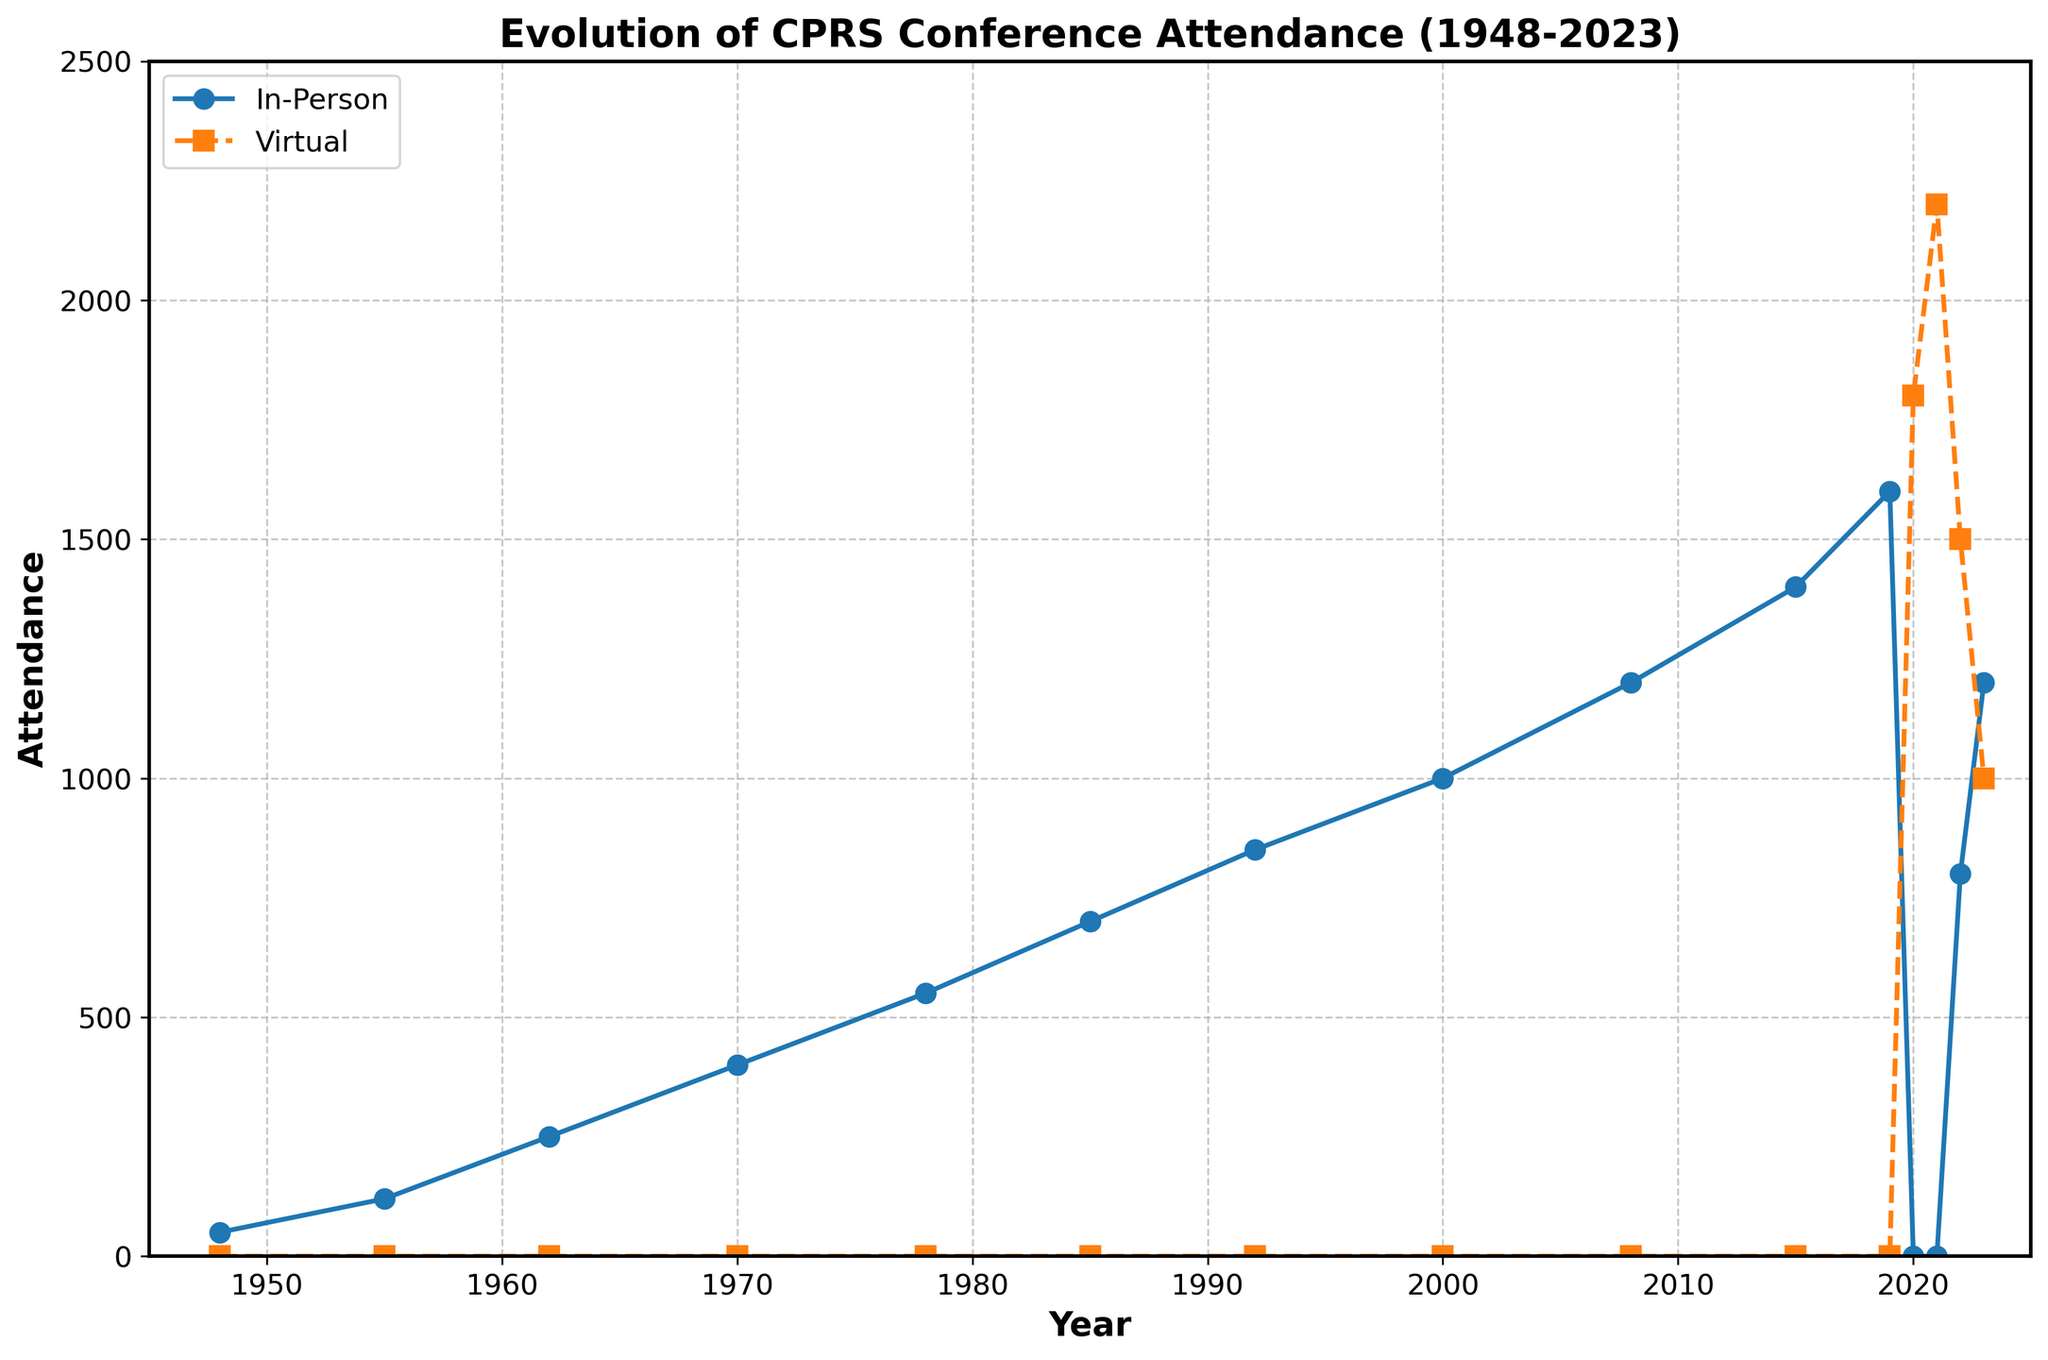What was the in-person attendance in 1978? Refer to the in-person attendance line on the chart and look at the year 1978. The chart shows a dot at 550 for this year.
Answer: 550 How did the virtual attendance in 2020 compare to in-person attendance in 2019? For 2020, the virtual attendance was 1800, and in 2019, the in-person attendance was 1600. Comparing these, 1800 is greater than 1600.
Answer: Virtual attendance in 2020 was higher What is the difference between total attendance (in-person plus virtual) in 2020 and 2022? In 2020, total attendance was 1800 (since only virtual attendance was present). In 2022, total attendance equals 800 (in-person) + 1500 (virtual) = 2300. Subtract 1800 from 2300.
Answer: 500 Which year saw the highest virtual attendance? Look at the virtual attendance (dashed line) and identify the highest point, which is in 2021 with an attendance of 2200.
Answer: 2021 How did the in-person attendance trend change between 2019 and 2023? Refer to the in-person attendance line on the chart. From 2019 (1600), the attendance dropped to 0 in 2020 and 2021, then rose to 800 in 2022 and further to 1200 in 2023.
Answer: It dropped to zero and then gradually increased What year saw the first introduction of virtual attendance? Observe the virtual attendance line (dashed). The first nonzero value appears in 2020.
Answer: 2020 What is the average in-person attendance from 1948 to 2023? Sum the in-person attendance values and divide by the number of years where in-person attendance is recorded: (50+120+250+400+550+700+850+1000+1200+1400+1600+800+1200) / 13.
Answer: 800 What is the combined in-person and virtual attendance in 2023? Check the values for in-person (1200) and virtual attendance (1000) for the year 2023 and sum them up: 1200 + 1000 = 2200.
Answer: 2200 How many years had higher in-person attendance than 2015? Look at the in-person attendance values and see how many are above 1400 (the value in 2015). Only 2019 fits this criterion.
Answer: 1 year Was virtual attendance ever higher than the highest recorded in-person attendance? The highest in-person attendance is 1600 (in 2019). The virtual attendance peaked at 2200 (in 2021). Compare these values: 2200 > 1600.
Answer: Yes 